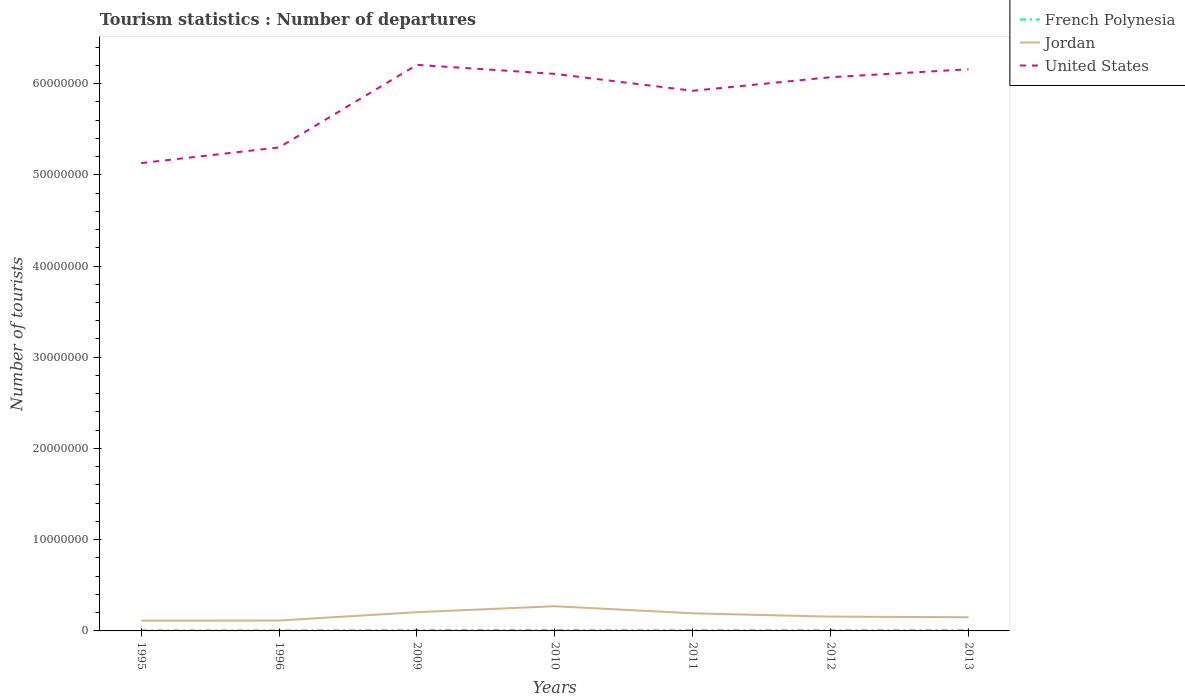Does the line corresponding to French Polynesia intersect with the line corresponding to Jordan?
Your response must be concise. No. Across all years, what is the maximum number of tourist departures in United States?
Ensure brevity in your answer.  5.13e+07. What is the total number of tourist departures in Jordan in the graph?
Provide a short and direct response. -4.39e+05. What is the difference between the highest and the second highest number of tourist departures in French Polynesia?
Make the answer very short. 2.60e+04. What is the difference between the highest and the lowest number of tourist departures in Jordan?
Offer a terse response. 3. What is the difference between two consecutive major ticks on the Y-axis?
Give a very brief answer. 1.00e+07. Does the graph contain any zero values?
Keep it short and to the point. No. Where does the legend appear in the graph?
Make the answer very short. Top right. How many legend labels are there?
Offer a terse response. 3. How are the legend labels stacked?
Provide a short and direct response. Vertical. What is the title of the graph?
Give a very brief answer. Tourism statistics : Number of departures. Does "Latin America(all income levels)" appear as one of the legend labels in the graph?
Your response must be concise. No. What is the label or title of the Y-axis?
Offer a terse response. Number of tourists. What is the Number of tourists in French Polynesia in 1995?
Your response must be concise. 6.30e+04. What is the Number of tourists of Jordan in 1995?
Make the answer very short. 1.13e+06. What is the Number of tourists of United States in 1995?
Provide a succinct answer. 5.13e+07. What is the Number of tourists of French Polynesia in 1996?
Your response must be concise. 6.50e+04. What is the Number of tourists of Jordan in 1996?
Give a very brief answer. 1.14e+06. What is the Number of tourists of United States in 1996?
Provide a succinct answer. 5.30e+07. What is the Number of tourists in French Polynesia in 2009?
Your answer should be compact. 8.80e+04. What is the Number of tourists of Jordan in 2009?
Make the answer very short. 2.05e+06. What is the Number of tourists of United States in 2009?
Give a very brief answer. 6.21e+07. What is the Number of tourists of French Polynesia in 2010?
Provide a succinct answer. 8.90e+04. What is the Number of tourists of Jordan in 2010?
Offer a very short reply. 2.71e+06. What is the Number of tourists in United States in 2010?
Make the answer very short. 6.11e+07. What is the Number of tourists of French Polynesia in 2011?
Provide a short and direct response. 8.40e+04. What is the Number of tourists in Jordan in 2011?
Make the answer very short. 1.93e+06. What is the Number of tourists of United States in 2011?
Provide a short and direct response. 5.92e+07. What is the Number of tourists in French Polynesia in 2012?
Your answer should be very brief. 8.30e+04. What is the Number of tourists in Jordan in 2012?
Offer a very short reply. 1.57e+06. What is the Number of tourists in United States in 2012?
Make the answer very short. 6.07e+07. What is the Number of tourists in Jordan in 2013?
Your answer should be very brief. 1.50e+06. What is the Number of tourists in United States in 2013?
Ensure brevity in your answer.  6.16e+07. Across all years, what is the maximum Number of tourists of French Polynesia?
Your answer should be very brief. 8.90e+04. Across all years, what is the maximum Number of tourists of Jordan?
Ensure brevity in your answer.  2.71e+06. Across all years, what is the maximum Number of tourists of United States?
Offer a terse response. 6.21e+07. Across all years, what is the minimum Number of tourists of French Polynesia?
Provide a succinct answer. 6.30e+04. Across all years, what is the minimum Number of tourists of Jordan?
Your response must be concise. 1.13e+06. Across all years, what is the minimum Number of tourists in United States?
Give a very brief answer. 5.13e+07. What is the total Number of tourists in French Polynesia in the graph?
Offer a very short reply. 5.52e+05. What is the total Number of tourists of Jordan in the graph?
Keep it short and to the point. 1.20e+07. What is the total Number of tourists of United States in the graph?
Provide a succinct answer. 4.09e+08. What is the difference between the Number of tourists in French Polynesia in 1995 and that in 1996?
Offer a terse response. -2000. What is the difference between the Number of tourists of Jordan in 1995 and that in 1996?
Provide a succinct answer. -1.30e+04. What is the difference between the Number of tourists of United States in 1995 and that in 1996?
Provide a succinct answer. -1.71e+06. What is the difference between the Number of tourists in French Polynesia in 1995 and that in 2009?
Your response must be concise. -2.50e+04. What is the difference between the Number of tourists of Jordan in 1995 and that in 2009?
Your response must be concise. -9.26e+05. What is the difference between the Number of tourists in United States in 1995 and that in 2009?
Your answer should be compact. -1.08e+07. What is the difference between the Number of tourists in French Polynesia in 1995 and that in 2010?
Your answer should be very brief. -2.60e+04. What is the difference between the Number of tourists in Jordan in 1995 and that in 2010?
Your answer should be very brief. -1.58e+06. What is the difference between the Number of tourists in United States in 1995 and that in 2010?
Provide a succinct answer. -9.78e+06. What is the difference between the Number of tourists of French Polynesia in 1995 and that in 2011?
Make the answer very short. -2.10e+04. What is the difference between the Number of tourists in Jordan in 1995 and that in 2011?
Provide a succinct answer. -8.03e+05. What is the difference between the Number of tourists in United States in 1995 and that in 2011?
Your answer should be very brief. -7.92e+06. What is the difference between the Number of tourists in French Polynesia in 1995 and that in 2012?
Provide a short and direct response. -2.00e+04. What is the difference between the Number of tourists of Jordan in 1995 and that in 2012?
Offer a very short reply. -4.39e+05. What is the difference between the Number of tourists in United States in 1995 and that in 2012?
Offer a very short reply. -9.41e+06. What is the difference between the Number of tourists in French Polynesia in 1995 and that in 2013?
Keep it short and to the point. -1.70e+04. What is the difference between the Number of tourists in Jordan in 1995 and that in 2013?
Offer a terse response. -3.70e+05. What is the difference between the Number of tourists in United States in 1995 and that in 2013?
Offer a terse response. -1.03e+07. What is the difference between the Number of tourists in French Polynesia in 1996 and that in 2009?
Ensure brevity in your answer.  -2.30e+04. What is the difference between the Number of tourists in Jordan in 1996 and that in 2009?
Your answer should be very brief. -9.13e+05. What is the difference between the Number of tourists in United States in 1996 and that in 2009?
Give a very brief answer. -9.05e+06. What is the difference between the Number of tourists of French Polynesia in 1996 and that in 2010?
Offer a terse response. -2.40e+04. What is the difference between the Number of tourists in Jordan in 1996 and that in 2010?
Keep it short and to the point. -1.57e+06. What is the difference between the Number of tourists of United States in 1996 and that in 2010?
Ensure brevity in your answer.  -8.06e+06. What is the difference between the Number of tourists in French Polynesia in 1996 and that in 2011?
Your answer should be very brief. -1.90e+04. What is the difference between the Number of tourists in Jordan in 1996 and that in 2011?
Offer a very short reply. -7.90e+05. What is the difference between the Number of tourists of United States in 1996 and that in 2011?
Your answer should be very brief. -6.21e+06. What is the difference between the Number of tourists in French Polynesia in 1996 and that in 2012?
Provide a short and direct response. -1.80e+04. What is the difference between the Number of tourists in Jordan in 1996 and that in 2012?
Make the answer very short. -4.26e+05. What is the difference between the Number of tourists of United States in 1996 and that in 2012?
Your answer should be compact. -7.70e+06. What is the difference between the Number of tourists in French Polynesia in 1996 and that in 2013?
Your response must be concise. -1.50e+04. What is the difference between the Number of tourists in Jordan in 1996 and that in 2013?
Provide a succinct answer. -3.57e+05. What is the difference between the Number of tourists of United States in 1996 and that in 2013?
Provide a short and direct response. -8.57e+06. What is the difference between the Number of tourists in French Polynesia in 2009 and that in 2010?
Your answer should be compact. -1000. What is the difference between the Number of tourists in Jordan in 2009 and that in 2010?
Give a very brief answer. -6.54e+05. What is the difference between the Number of tourists in United States in 2009 and that in 2010?
Offer a very short reply. 9.90e+05. What is the difference between the Number of tourists in French Polynesia in 2009 and that in 2011?
Make the answer very short. 4000. What is the difference between the Number of tourists of Jordan in 2009 and that in 2011?
Offer a terse response. 1.23e+05. What is the difference between the Number of tourists in United States in 2009 and that in 2011?
Make the answer very short. 2.84e+06. What is the difference between the Number of tourists of Jordan in 2009 and that in 2012?
Your answer should be compact. 4.87e+05. What is the difference between the Number of tourists of United States in 2009 and that in 2012?
Offer a terse response. 1.36e+06. What is the difference between the Number of tourists of French Polynesia in 2009 and that in 2013?
Your response must be concise. 8000. What is the difference between the Number of tourists in Jordan in 2009 and that in 2013?
Provide a short and direct response. 5.56e+05. What is the difference between the Number of tourists in United States in 2009 and that in 2013?
Provide a short and direct response. 4.82e+05. What is the difference between the Number of tourists in Jordan in 2010 and that in 2011?
Your answer should be compact. 7.77e+05. What is the difference between the Number of tourists in United States in 2010 and that in 2011?
Provide a succinct answer. 1.85e+06. What is the difference between the Number of tourists in French Polynesia in 2010 and that in 2012?
Your response must be concise. 6000. What is the difference between the Number of tourists in Jordan in 2010 and that in 2012?
Make the answer very short. 1.14e+06. What is the difference between the Number of tourists in United States in 2010 and that in 2012?
Your response must be concise. 3.65e+05. What is the difference between the Number of tourists in French Polynesia in 2010 and that in 2013?
Provide a succinct answer. 9000. What is the difference between the Number of tourists in Jordan in 2010 and that in 2013?
Offer a very short reply. 1.21e+06. What is the difference between the Number of tourists of United States in 2010 and that in 2013?
Your answer should be compact. -5.08e+05. What is the difference between the Number of tourists in Jordan in 2011 and that in 2012?
Offer a very short reply. 3.64e+05. What is the difference between the Number of tourists in United States in 2011 and that in 2012?
Your response must be concise. -1.49e+06. What is the difference between the Number of tourists in French Polynesia in 2011 and that in 2013?
Give a very brief answer. 4000. What is the difference between the Number of tourists in Jordan in 2011 and that in 2013?
Your response must be concise. 4.33e+05. What is the difference between the Number of tourists of United States in 2011 and that in 2013?
Keep it short and to the point. -2.36e+06. What is the difference between the Number of tourists in French Polynesia in 2012 and that in 2013?
Ensure brevity in your answer.  3000. What is the difference between the Number of tourists of Jordan in 2012 and that in 2013?
Make the answer very short. 6.90e+04. What is the difference between the Number of tourists in United States in 2012 and that in 2013?
Offer a very short reply. -8.73e+05. What is the difference between the Number of tourists of French Polynesia in 1995 and the Number of tourists of Jordan in 1996?
Keep it short and to the point. -1.08e+06. What is the difference between the Number of tourists of French Polynesia in 1995 and the Number of tourists of United States in 1996?
Offer a very short reply. -5.29e+07. What is the difference between the Number of tourists in Jordan in 1995 and the Number of tourists in United States in 1996?
Your response must be concise. -5.19e+07. What is the difference between the Number of tourists in French Polynesia in 1995 and the Number of tourists in Jordan in 2009?
Your response must be concise. -1.99e+06. What is the difference between the Number of tourists of French Polynesia in 1995 and the Number of tourists of United States in 2009?
Your answer should be very brief. -6.20e+07. What is the difference between the Number of tourists in Jordan in 1995 and the Number of tourists in United States in 2009?
Provide a short and direct response. -6.09e+07. What is the difference between the Number of tourists in French Polynesia in 1995 and the Number of tourists in Jordan in 2010?
Your answer should be compact. -2.64e+06. What is the difference between the Number of tourists in French Polynesia in 1995 and the Number of tourists in United States in 2010?
Offer a very short reply. -6.10e+07. What is the difference between the Number of tourists of Jordan in 1995 and the Number of tourists of United States in 2010?
Offer a terse response. -5.99e+07. What is the difference between the Number of tourists in French Polynesia in 1995 and the Number of tourists in Jordan in 2011?
Keep it short and to the point. -1.87e+06. What is the difference between the Number of tourists of French Polynesia in 1995 and the Number of tourists of United States in 2011?
Ensure brevity in your answer.  -5.91e+07. What is the difference between the Number of tourists of Jordan in 1995 and the Number of tourists of United States in 2011?
Ensure brevity in your answer.  -5.81e+07. What is the difference between the Number of tourists in French Polynesia in 1995 and the Number of tourists in Jordan in 2012?
Your response must be concise. -1.50e+06. What is the difference between the Number of tourists in French Polynesia in 1995 and the Number of tourists in United States in 2012?
Your response must be concise. -6.06e+07. What is the difference between the Number of tourists in Jordan in 1995 and the Number of tourists in United States in 2012?
Your response must be concise. -5.96e+07. What is the difference between the Number of tourists in French Polynesia in 1995 and the Number of tourists in Jordan in 2013?
Your answer should be compact. -1.44e+06. What is the difference between the Number of tourists of French Polynesia in 1995 and the Number of tourists of United States in 2013?
Give a very brief answer. -6.15e+07. What is the difference between the Number of tourists of Jordan in 1995 and the Number of tourists of United States in 2013?
Offer a very short reply. -6.04e+07. What is the difference between the Number of tourists of French Polynesia in 1996 and the Number of tourists of Jordan in 2009?
Make the answer very short. -1.99e+06. What is the difference between the Number of tourists of French Polynesia in 1996 and the Number of tourists of United States in 2009?
Offer a terse response. -6.20e+07. What is the difference between the Number of tourists in Jordan in 1996 and the Number of tourists in United States in 2009?
Your answer should be compact. -6.09e+07. What is the difference between the Number of tourists in French Polynesia in 1996 and the Number of tourists in Jordan in 2010?
Ensure brevity in your answer.  -2.64e+06. What is the difference between the Number of tourists of French Polynesia in 1996 and the Number of tourists of United States in 2010?
Give a very brief answer. -6.10e+07. What is the difference between the Number of tourists in Jordan in 1996 and the Number of tourists in United States in 2010?
Give a very brief answer. -5.99e+07. What is the difference between the Number of tourists of French Polynesia in 1996 and the Number of tourists of Jordan in 2011?
Your answer should be very brief. -1.87e+06. What is the difference between the Number of tourists of French Polynesia in 1996 and the Number of tourists of United States in 2011?
Ensure brevity in your answer.  -5.91e+07. What is the difference between the Number of tourists of Jordan in 1996 and the Number of tourists of United States in 2011?
Ensure brevity in your answer.  -5.81e+07. What is the difference between the Number of tourists of French Polynesia in 1996 and the Number of tourists of Jordan in 2012?
Make the answer very short. -1.50e+06. What is the difference between the Number of tourists in French Polynesia in 1996 and the Number of tourists in United States in 2012?
Ensure brevity in your answer.  -6.06e+07. What is the difference between the Number of tourists in Jordan in 1996 and the Number of tourists in United States in 2012?
Keep it short and to the point. -5.96e+07. What is the difference between the Number of tourists of French Polynesia in 1996 and the Number of tourists of Jordan in 2013?
Provide a succinct answer. -1.43e+06. What is the difference between the Number of tourists of French Polynesia in 1996 and the Number of tourists of United States in 2013?
Offer a very short reply. -6.15e+07. What is the difference between the Number of tourists of Jordan in 1996 and the Number of tourists of United States in 2013?
Offer a terse response. -6.04e+07. What is the difference between the Number of tourists of French Polynesia in 2009 and the Number of tourists of Jordan in 2010?
Provide a succinct answer. -2.62e+06. What is the difference between the Number of tourists in French Polynesia in 2009 and the Number of tourists in United States in 2010?
Your answer should be compact. -6.10e+07. What is the difference between the Number of tourists in Jordan in 2009 and the Number of tourists in United States in 2010?
Provide a short and direct response. -5.90e+07. What is the difference between the Number of tourists of French Polynesia in 2009 and the Number of tourists of Jordan in 2011?
Provide a short and direct response. -1.84e+06. What is the difference between the Number of tourists of French Polynesia in 2009 and the Number of tourists of United States in 2011?
Your answer should be compact. -5.91e+07. What is the difference between the Number of tourists of Jordan in 2009 and the Number of tourists of United States in 2011?
Your answer should be very brief. -5.72e+07. What is the difference between the Number of tourists of French Polynesia in 2009 and the Number of tourists of Jordan in 2012?
Your response must be concise. -1.48e+06. What is the difference between the Number of tourists of French Polynesia in 2009 and the Number of tourists of United States in 2012?
Give a very brief answer. -6.06e+07. What is the difference between the Number of tourists of Jordan in 2009 and the Number of tourists of United States in 2012?
Your response must be concise. -5.86e+07. What is the difference between the Number of tourists in French Polynesia in 2009 and the Number of tourists in Jordan in 2013?
Your answer should be compact. -1.41e+06. What is the difference between the Number of tourists in French Polynesia in 2009 and the Number of tourists in United States in 2013?
Offer a terse response. -6.15e+07. What is the difference between the Number of tourists in Jordan in 2009 and the Number of tourists in United States in 2013?
Provide a succinct answer. -5.95e+07. What is the difference between the Number of tourists of French Polynesia in 2010 and the Number of tourists of Jordan in 2011?
Offer a terse response. -1.84e+06. What is the difference between the Number of tourists in French Polynesia in 2010 and the Number of tourists in United States in 2011?
Your answer should be compact. -5.91e+07. What is the difference between the Number of tourists of Jordan in 2010 and the Number of tourists of United States in 2011?
Provide a succinct answer. -5.65e+07. What is the difference between the Number of tourists of French Polynesia in 2010 and the Number of tourists of Jordan in 2012?
Keep it short and to the point. -1.48e+06. What is the difference between the Number of tourists of French Polynesia in 2010 and the Number of tourists of United States in 2012?
Your answer should be compact. -6.06e+07. What is the difference between the Number of tourists in Jordan in 2010 and the Number of tourists in United States in 2012?
Provide a short and direct response. -5.80e+07. What is the difference between the Number of tourists in French Polynesia in 2010 and the Number of tourists in Jordan in 2013?
Give a very brief answer. -1.41e+06. What is the difference between the Number of tourists of French Polynesia in 2010 and the Number of tourists of United States in 2013?
Keep it short and to the point. -6.15e+07. What is the difference between the Number of tourists in Jordan in 2010 and the Number of tourists in United States in 2013?
Your answer should be compact. -5.89e+07. What is the difference between the Number of tourists of French Polynesia in 2011 and the Number of tourists of Jordan in 2012?
Provide a succinct answer. -1.48e+06. What is the difference between the Number of tourists of French Polynesia in 2011 and the Number of tourists of United States in 2012?
Your response must be concise. -6.06e+07. What is the difference between the Number of tourists of Jordan in 2011 and the Number of tourists of United States in 2012?
Provide a short and direct response. -5.88e+07. What is the difference between the Number of tourists of French Polynesia in 2011 and the Number of tourists of Jordan in 2013?
Provide a succinct answer. -1.41e+06. What is the difference between the Number of tourists of French Polynesia in 2011 and the Number of tourists of United States in 2013?
Provide a succinct answer. -6.15e+07. What is the difference between the Number of tourists of Jordan in 2011 and the Number of tourists of United States in 2013?
Your response must be concise. -5.96e+07. What is the difference between the Number of tourists of French Polynesia in 2012 and the Number of tourists of Jordan in 2013?
Offer a terse response. -1.42e+06. What is the difference between the Number of tourists in French Polynesia in 2012 and the Number of tourists in United States in 2013?
Keep it short and to the point. -6.15e+07. What is the difference between the Number of tourists of Jordan in 2012 and the Number of tourists of United States in 2013?
Your answer should be compact. -6.00e+07. What is the average Number of tourists in French Polynesia per year?
Your answer should be compact. 7.89e+04. What is the average Number of tourists of Jordan per year?
Keep it short and to the point. 1.72e+06. What is the average Number of tourists of United States per year?
Keep it short and to the point. 5.84e+07. In the year 1995, what is the difference between the Number of tourists of French Polynesia and Number of tourists of Jordan?
Keep it short and to the point. -1.06e+06. In the year 1995, what is the difference between the Number of tourists of French Polynesia and Number of tourists of United States?
Keep it short and to the point. -5.12e+07. In the year 1995, what is the difference between the Number of tourists in Jordan and Number of tourists in United States?
Give a very brief answer. -5.02e+07. In the year 1996, what is the difference between the Number of tourists of French Polynesia and Number of tourists of Jordan?
Make the answer very short. -1.08e+06. In the year 1996, what is the difference between the Number of tourists in French Polynesia and Number of tourists in United States?
Your answer should be very brief. -5.29e+07. In the year 1996, what is the difference between the Number of tourists of Jordan and Number of tourists of United States?
Give a very brief answer. -5.19e+07. In the year 2009, what is the difference between the Number of tourists of French Polynesia and Number of tourists of Jordan?
Give a very brief answer. -1.97e+06. In the year 2009, what is the difference between the Number of tourists in French Polynesia and Number of tourists in United States?
Make the answer very short. -6.20e+07. In the year 2009, what is the difference between the Number of tourists of Jordan and Number of tourists of United States?
Make the answer very short. -6.00e+07. In the year 2010, what is the difference between the Number of tourists of French Polynesia and Number of tourists of Jordan?
Offer a terse response. -2.62e+06. In the year 2010, what is the difference between the Number of tourists of French Polynesia and Number of tourists of United States?
Your answer should be very brief. -6.10e+07. In the year 2010, what is the difference between the Number of tourists of Jordan and Number of tourists of United States?
Your answer should be compact. -5.84e+07. In the year 2011, what is the difference between the Number of tourists in French Polynesia and Number of tourists in Jordan?
Your answer should be very brief. -1.85e+06. In the year 2011, what is the difference between the Number of tourists in French Polynesia and Number of tourists in United States?
Offer a very short reply. -5.91e+07. In the year 2011, what is the difference between the Number of tourists of Jordan and Number of tourists of United States?
Make the answer very short. -5.73e+07. In the year 2012, what is the difference between the Number of tourists in French Polynesia and Number of tourists in Jordan?
Provide a short and direct response. -1.48e+06. In the year 2012, what is the difference between the Number of tourists in French Polynesia and Number of tourists in United States?
Offer a terse response. -6.06e+07. In the year 2012, what is the difference between the Number of tourists in Jordan and Number of tourists in United States?
Provide a succinct answer. -5.91e+07. In the year 2013, what is the difference between the Number of tourists in French Polynesia and Number of tourists in Jordan?
Ensure brevity in your answer.  -1.42e+06. In the year 2013, what is the difference between the Number of tourists in French Polynesia and Number of tourists in United States?
Your answer should be very brief. -6.15e+07. In the year 2013, what is the difference between the Number of tourists of Jordan and Number of tourists of United States?
Make the answer very short. -6.01e+07. What is the ratio of the Number of tourists in French Polynesia in 1995 to that in 1996?
Keep it short and to the point. 0.97. What is the ratio of the Number of tourists in United States in 1995 to that in 1996?
Provide a short and direct response. 0.97. What is the ratio of the Number of tourists of French Polynesia in 1995 to that in 2009?
Your answer should be very brief. 0.72. What is the ratio of the Number of tourists of Jordan in 1995 to that in 2009?
Offer a terse response. 0.55. What is the ratio of the Number of tourists of United States in 1995 to that in 2009?
Your response must be concise. 0.83. What is the ratio of the Number of tourists in French Polynesia in 1995 to that in 2010?
Make the answer very short. 0.71. What is the ratio of the Number of tourists of Jordan in 1995 to that in 2010?
Provide a short and direct response. 0.42. What is the ratio of the Number of tourists of United States in 1995 to that in 2010?
Your response must be concise. 0.84. What is the ratio of the Number of tourists of Jordan in 1995 to that in 2011?
Provide a short and direct response. 0.58. What is the ratio of the Number of tourists of United States in 1995 to that in 2011?
Provide a succinct answer. 0.87. What is the ratio of the Number of tourists in French Polynesia in 1995 to that in 2012?
Make the answer very short. 0.76. What is the ratio of the Number of tourists of Jordan in 1995 to that in 2012?
Provide a succinct answer. 0.72. What is the ratio of the Number of tourists of United States in 1995 to that in 2012?
Provide a succinct answer. 0.84. What is the ratio of the Number of tourists of French Polynesia in 1995 to that in 2013?
Make the answer very short. 0.79. What is the ratio of the Number of tourists in Jordan in 1995 to that in 2013?
Give a very brief answer. 0.75. What is the ratio of the Number of tourists in United States in 1995 to that in 2013?
Keep it short and to the point. 0.83. What is the ratio of the Number of tourists of French Polynesia in 1996 to that in 2009?
Your response must be concise. 0.74. What is the ratio of the Number of tourists of Jordan in 1996 to that in 2009?
Your answer should be very brief. 0.56. What is the ratio of the Number of tourists in United States in 1996 to that in 2009?
Your answer should be very brief. 0.85. What is the ratio of the Number of tourists of French Polynesia in 1996 to that in 2010?
Provide a succinct answer. 0.73. What is the ratio of the Number of tourists of Jordan in 1996 to that in 2010?
Provide a succinct answer. 0.42. What is the ratio of the Number of tourists in United States in 1996 to that in 2010?
Your answer should be compact. 0.87. What is the ratio of the Number of tourists of French Polynesia in 1996 to that in 2011?
Your answer should be compact. 0.77. What is the ratio of the Number of tourists in Jordan in 1996 to that in 2011?
Your response must be concise. 0.59. What is the ratio of the Number of tourists of United States in 1996 to that in 2011?
Ensure brevity in your answer.  0.9. What is the ratio of the Number of tourists in French Polynesia in 1996 to that in 2012?
Your response must be concise. 0.78. What is the ratio of the Number of tourists of Jordan in 1996 to that in 2012?
Provide a short and direct response. 0.73. What is the ratio of the Number of tourists in United States in 1996 to that in 2012?
Offer a terse response. 0.87. What is the ratio of the Number of tourists in French Polynesia in 1996 to that in 2013?
Offer a terse response. 0.81. What is the ratio of the Number of tourists in Jordan in 1996 to that in 2013?
Provide a succinct answer. 0.76. What is the ratio of the Number of tourists of United States in 1996 to that in 2013?
Your answer should be very brief. 0.86. What is the ratio of the Number of tourists in French Polynesia in 2009 to that in 2010?
Provide a short and direct response. 0.99. What is the ratio of the Number of tourists of Jordan in 2009 to that in 2010?
Offer a very short reply. 0.76. What is the ratio of the Number of tourists of United States in 2009 to that in 2010?
Make the answer very short. 1.02. What is the ratio of the Number of tourists in French Polynesia in 2009 to that in 2011?
Your answer should be very brief. 1.05. What is the ratio of the Number of tourists of Jordan in 2009 to that in 2011?
Your answer should be very brief. 1.06. What is the ratio of the Number of tourists of United States in 2009 to that in 2011?
Keep it short and to the point. 1.05. What is the ratio of the Number of tourists in French Polynesia in 2009 to that in 2012?
Make the answer very short. 1.06. What is the ratio of the Number of tourists in Jordan in 2009 to that in 2012?
Your answer should be very brief. 1.31. What is the ratio of the Number of tourists in United States in 2009 to that in 2012?
Your response must be concise. 1.02. What is the ratio of the Number of tourists of Jordan in 2009 to that in 2013?
Keep it short and to the point. 1.37. What is the ratio of the Number of tourists in French Polynesia in 2010 to that in 2011?
Your answer should be very brief. 1.06. What is the ratio of the Number of tourists of Jordan in 2010 to that in 2011?
Your response must be concise. 1.4. What is the ratio of the Number of tourists in United States in 2010 to that in 2011?
Provide a succinct answer. 1.03. What is the ratio of the Number of tourists in French Polynesia in 2010 to that in 2012?
Your response must be concise. 1.07. What is the ratio of the Number of tourists of Jordan in 2010 to that in 2012?
Provide a succinct answer. 1.73. What is the ratio of the Number of tourists of United States in 2010 to that in 2012?
Give a very brief answer. 1.01. What is the ratio of the Number of tourists of French Polynesia in 2010 to that in 2013?
Your answer should be compact. 1.11. What is the ratio of the Number of tourists of Jordan in 2010 to that in 2013?
Give a very brief answer. 1.81. What is the ratio of the Number of tourists in United States in 2010 to that in 2013?
Give a very brief answer. 0.99. What is the ratio of the Number of tourists of Jordan in 2011 to that in 2012?
Make the answer very short. 1.23. What is the ratio of the Number of tourists of United States in 2011 to that in 2012?
Provide a short and direct response. 0.98. What is the ratio of the Number of tourists of French Polynesia in 2011 to that in 2013?
Your answer should be compact. 1.05. What is the ratio of the Number of tourists in Jordan in 2011 to that in 2013?
Offer a terse response. 1.29. What is the ratio of the Number of tourists in United States in 2011 to that in 2013?
Keep it short and to the point. 0.96. What is the ratio of the Number of tourists in French Polynesia in 2012 to that in 2013?
Provide a short and direct response. 1.04. What is the ratio of the Number of tourists in Jordan in 2012 to that in 2013?
Your answer should be compact. 1.05. What is the ratio of the Number of tourists in United States in 2012 to that in 2013?
Make the answer very short. 0.99. What is the difference between the highest and the second highest Number of tourists of French Polynesia?
Provide a succinct answer. 1000. What is the difference between the highest and the second highest Number of tourists of Jordan?
Make the answer very short. 6.54e+05. What is the difference between the highest and the second highest Number of tourists in United States?
Offer a terse response. 4.82e+05. What is the difference between the highest and the lowest Number of tourists in French Polynesia?
Provide a succinct answer. 2.60e+04. What is the difference between the highest and the lowest Number of tourists in Jordan?
Offer a terse response. 1.58e+06. What is the difference between the highest and the lowest Number of tourists of United States?
Offer a very short reply. 1.08e+07. 